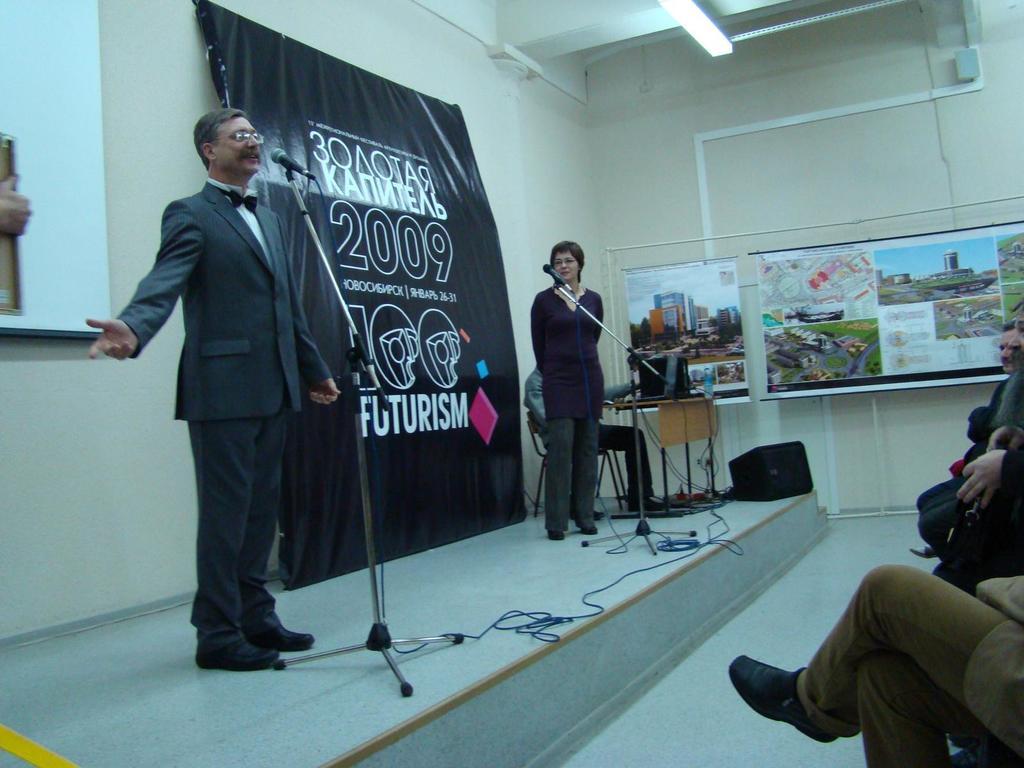What year was this taken?
Your answer should be very brief. 2009. What text is on the background?
Make the answer very short. Futurism. 